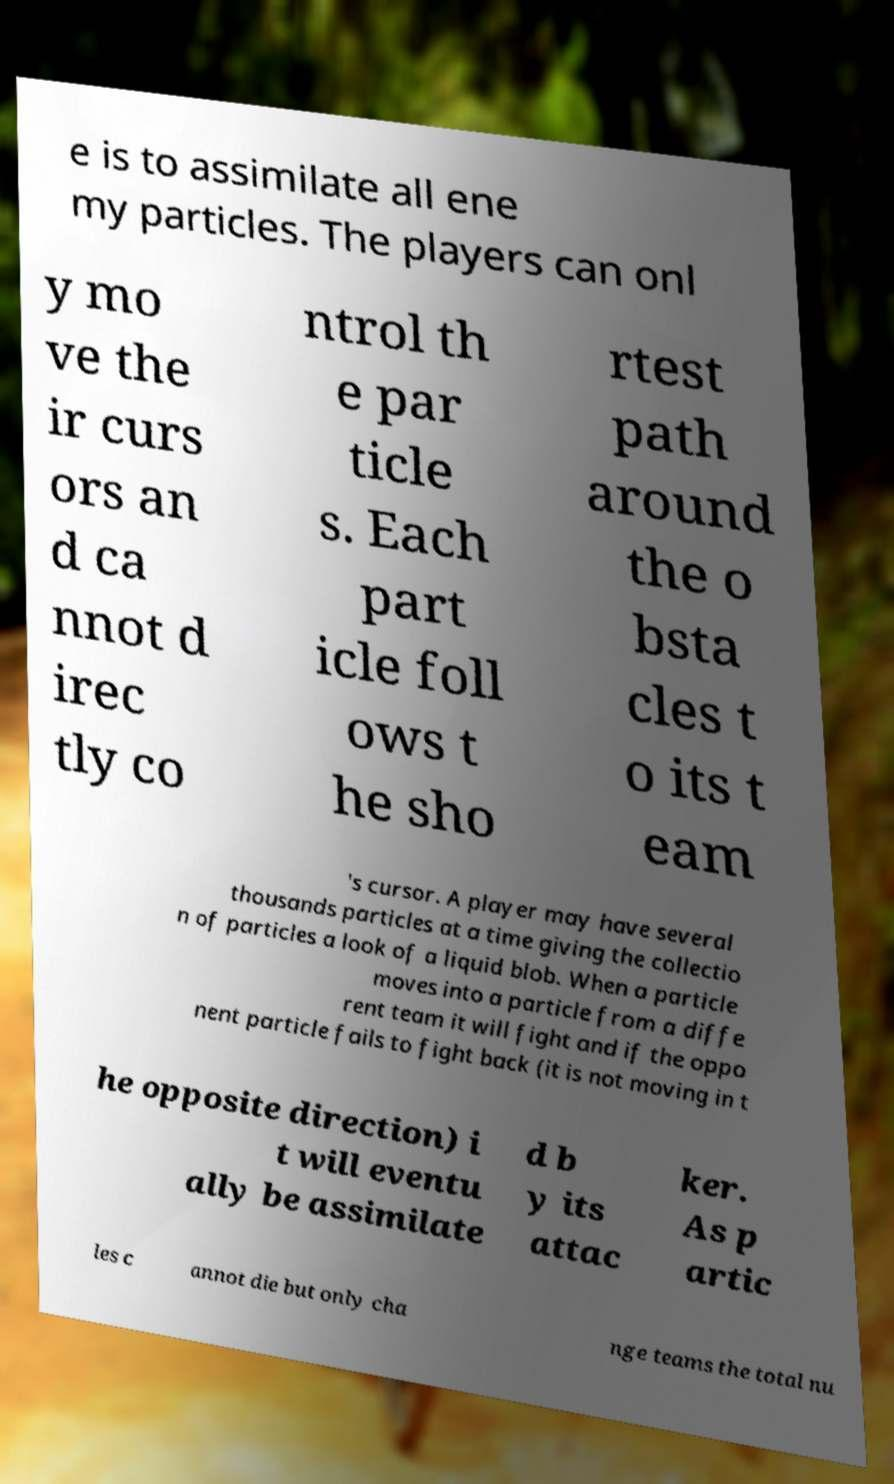Could you extract and type out the text from this image? e is to assimilate all ene my particles. The players can onl y mo ve the ir curs ors an d ca nnot d irec tly co ntrol th e par ticle s. Each part icle foll ows t he sho rtest path around the o bsta cles t o its t eam 's cursor. A player may have several thousands particles at a time giving the collectio n of particles a look of a liquid blob. When a particle moves into a particle from a diffe rent team it will fight and if the oppo nent particle fails to fight back (it is not moving in t he opposite direction) i t will eventu ally be assimilate d b y its attac ker. As p artic les c annot die but only cha nge teams the total nu 